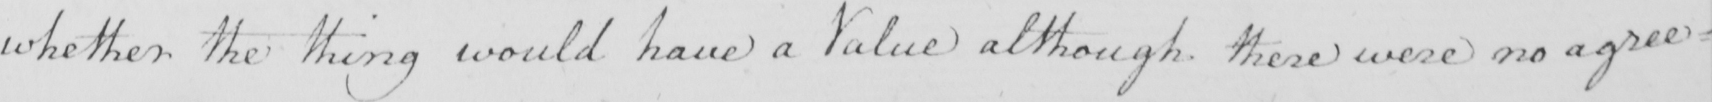Please transcribe the handwritten text in this image. whether the thing would have a Value although there were no agree= 